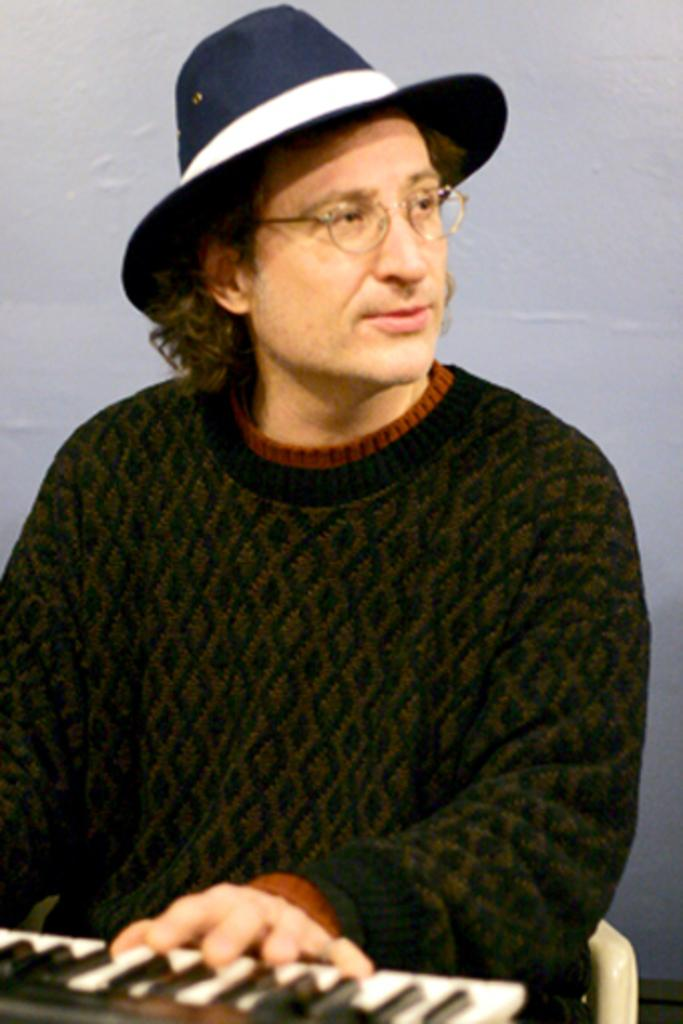What is the main subject of the image? The main subject of the image is a man. What is the man doing in the image? The man is playing a musical instrument in the image. Can you describe the man's position in the image? The man is sitting on a chair in the image. What is the man wearing on his head? The man is wearing a blue color hat in the image. What type of ornament is hanging from the musical instrument in the image? There is no ornament hanging from the musical instrument in the image. What joke is the man telling while playing the musical instrument in the image? There is no indication of a joke being told in the image; the man is simply playing the musical instrument. 